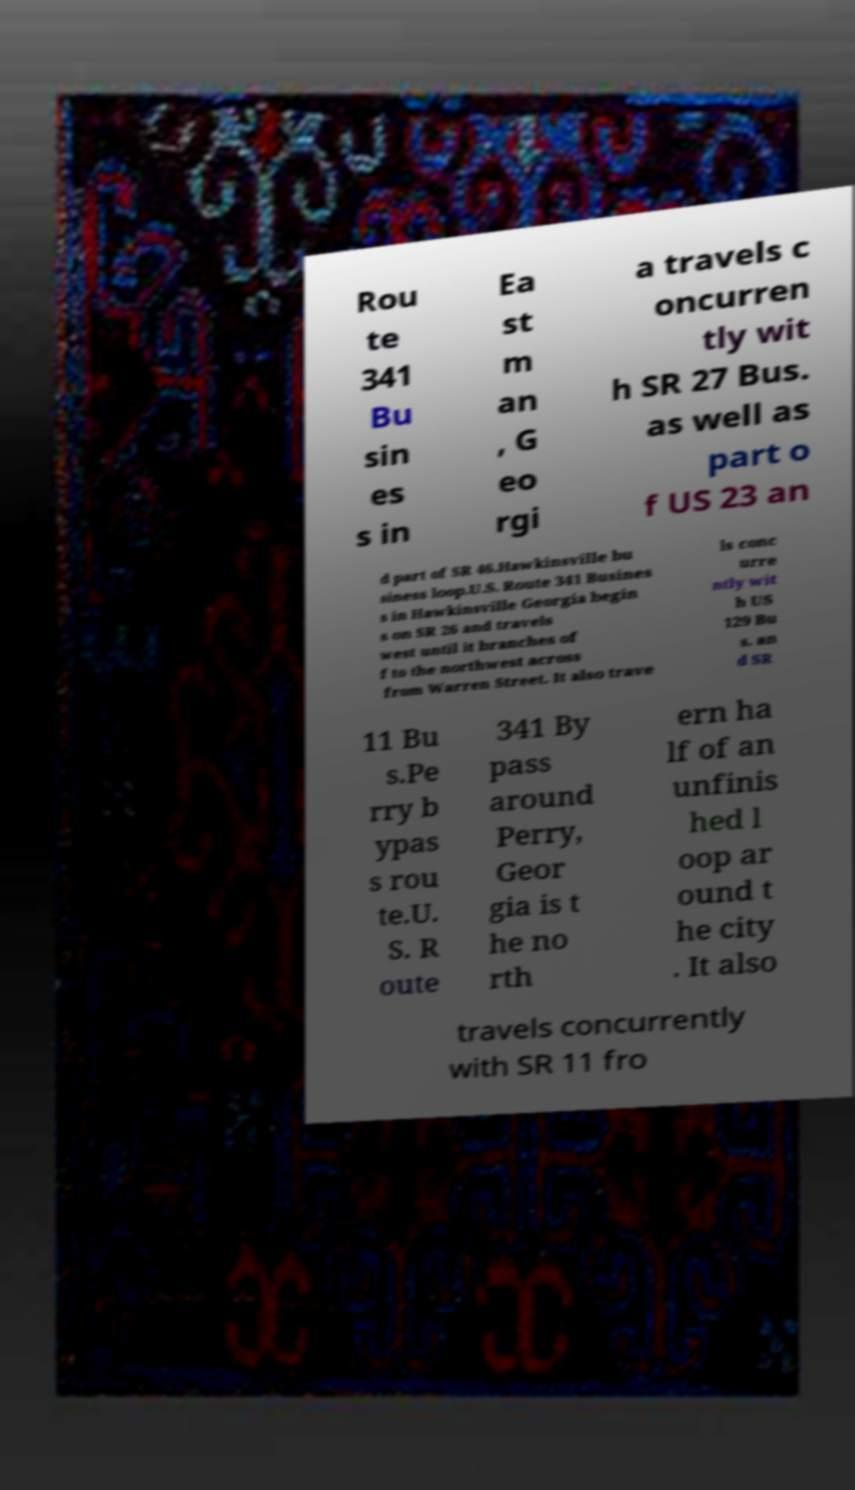Can you read and provide the text displayed in the image?This photo seems to have some interesting text. Can you extract and type it out for me? Rou te 341 Bu sin es s in Ea st m an , G eo rgi a travels c oncurren tly wit h SR 27 Bus. as well as part o f US 23 an d part of SR 46.Hawkinsville bu siness loop.U.S. Route 341 Busines s in Hawkinsville Georgia begin s on SR 26 and travels west until it branches of f to the northwest across from Warren Street. It also trave ls conc urre ntly wit h US 129 Bu s. an d SR 11 Bu s.Pe rry b ypas s rou te.U. S. R oute 341 By pass around Perry, Geor gia is t he no rth ern ha lf of an unfinis hed l oop ar ound t he city . It also travels concurrently with SR 11 fro 